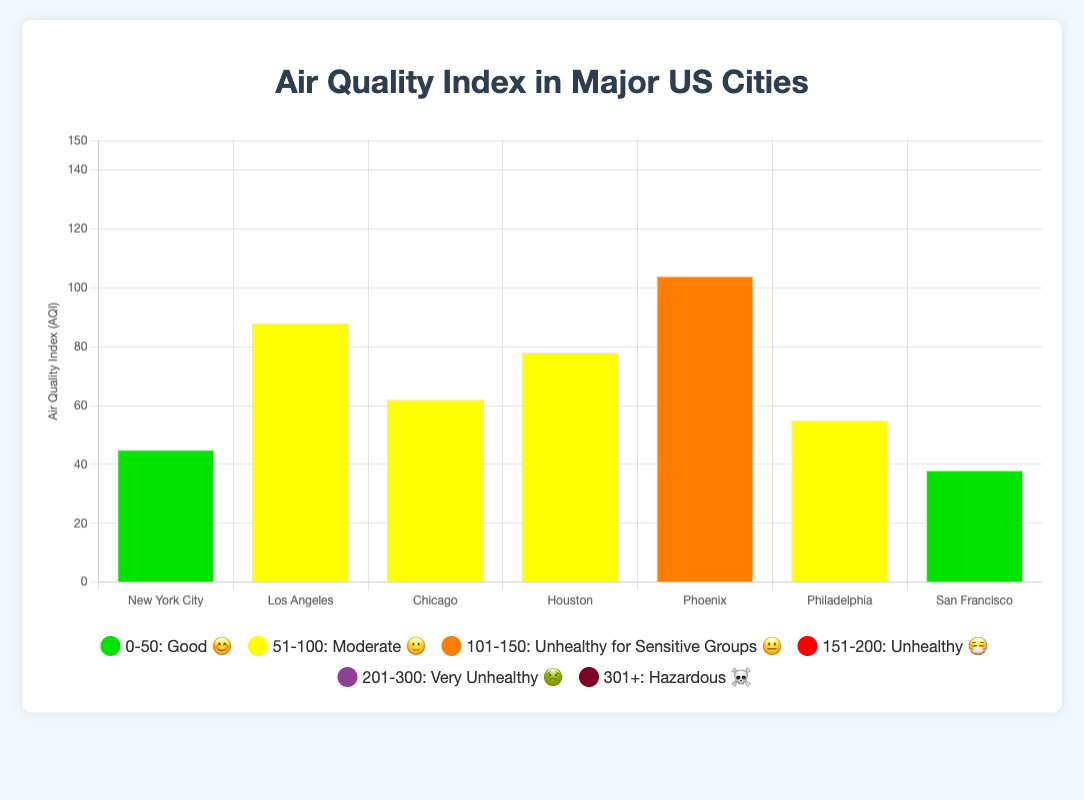What is the highest AQI among the cities? Look at the bar heights to find the highest bar, which corresponds to the city with the highest AQI value. Phoenix shows the tallest bar with an AQI of 104.
Answer: 104 Which city has the lowest AQI? Identify the shortest bar in the chart, which corresponds to the city with the lowest AQI value. San Francisco has the shortest bar with an AQI of 38.
Answer: San Francisco How many cities fall under the "Good" AQI category (0-50)? Count the number of bars that are colored to represent the "Good" range (green). Both New York City and San Francisco fall into this category.
Answer: 2 What is the average AQI of all the cities combined? Sum the AQI values of all cities and divide by the number of cities: (45 + 88 + 62 + 78 + 104 + 55 + 38) / 7 = 470 / 7.
Answer: 67.14 Which city represents with a "😐" emoji? Look at the chart’s tooltip and find the city associated with the 😐 emoji among the displayed AQIs. Houston has an AQI of 78 and is associated with this emoji.
Answer: Houston Which city has a worse air quality, Los Angeles or Chicago? Compare the heights of the bars for Los Angeles and Chicago. Los Angeles has a higher AQI (88) compared to Chicago (62), indicating worse air quality.
Answer: Los Angeles What is the range and description of the AQI category indicated by the emoji "🤢"? Refer to the legend associated with the emojis to find that 😷 corresponds to the "Very Unhealthy" category with an AQI range of 201-300.
Answer: 201-300, Very Unhealthy How many cities have an AQI level categorized as "Moderate" (51-100)? Count the number of bars that fall within the Moderate range, indicated by yellow. Three cities (Los Angeles, Chicago, Philadelphia) have AQIs in this range.
Answer: 3 If we combine the AQI values of New York City and San Francisco, what is the result? Add the AQI values of New York City (45) and San Francisco (38): 45 + 38.
Answer: 83 Which city falls under the "Unhealthy for Sensitive Groups" category? Identify the bar with an AQI in the range 101-150, indicated by orange. Phoenix, with an AQI of 104, falls into this category.
Answer: Phoenix 